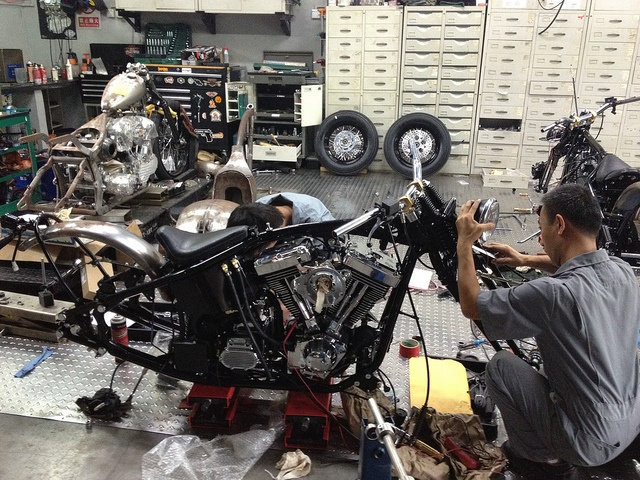Describe the objects in this image and their specific colors. I can see motorcycle in gray, black, darkgray, and lightgray tones, people in gray, black, darkgray, and maroon tones, motorcycle in gray, black, darkgray, and ivory tones, motorcycle in gray, black, lightgray, and darkgray tones, and motorcycle in gray, white, darkgray, and black tones in this image. 